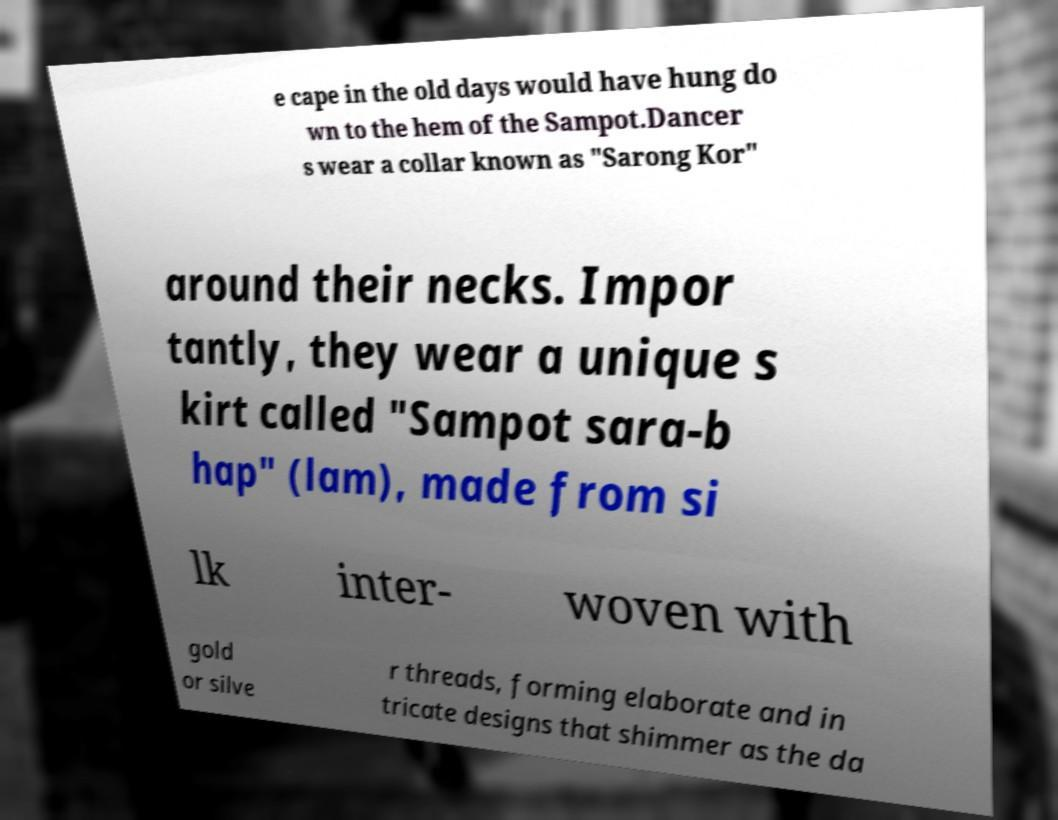Can you read and provide the text displayed in the image?This photo seems to have some interesting text. Can you extract and type it out for me? e cape in the old days would have hung do wn to the hem of the Sampot.Dancer s wear a collar known as "Sarong Kor" around their necks. Impor tantly, they wear a unique s kirt called "Sampot sara-b hap" (lam), made from si lk inter- woven with gold or silve r threads, forming elaborate and in tricate designs that shimmer as the da 